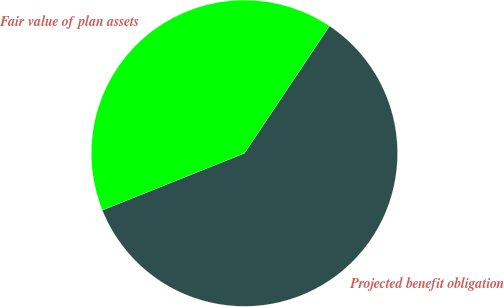Convert chart. <chart><loc_0><loc_0><loc_500><loc_500><pie_chart><fcel>Projected benefit obligation<fcel>Fair value of plan assets<nl><fcel>59.55%<fcel>40.45%<nl></chart> 